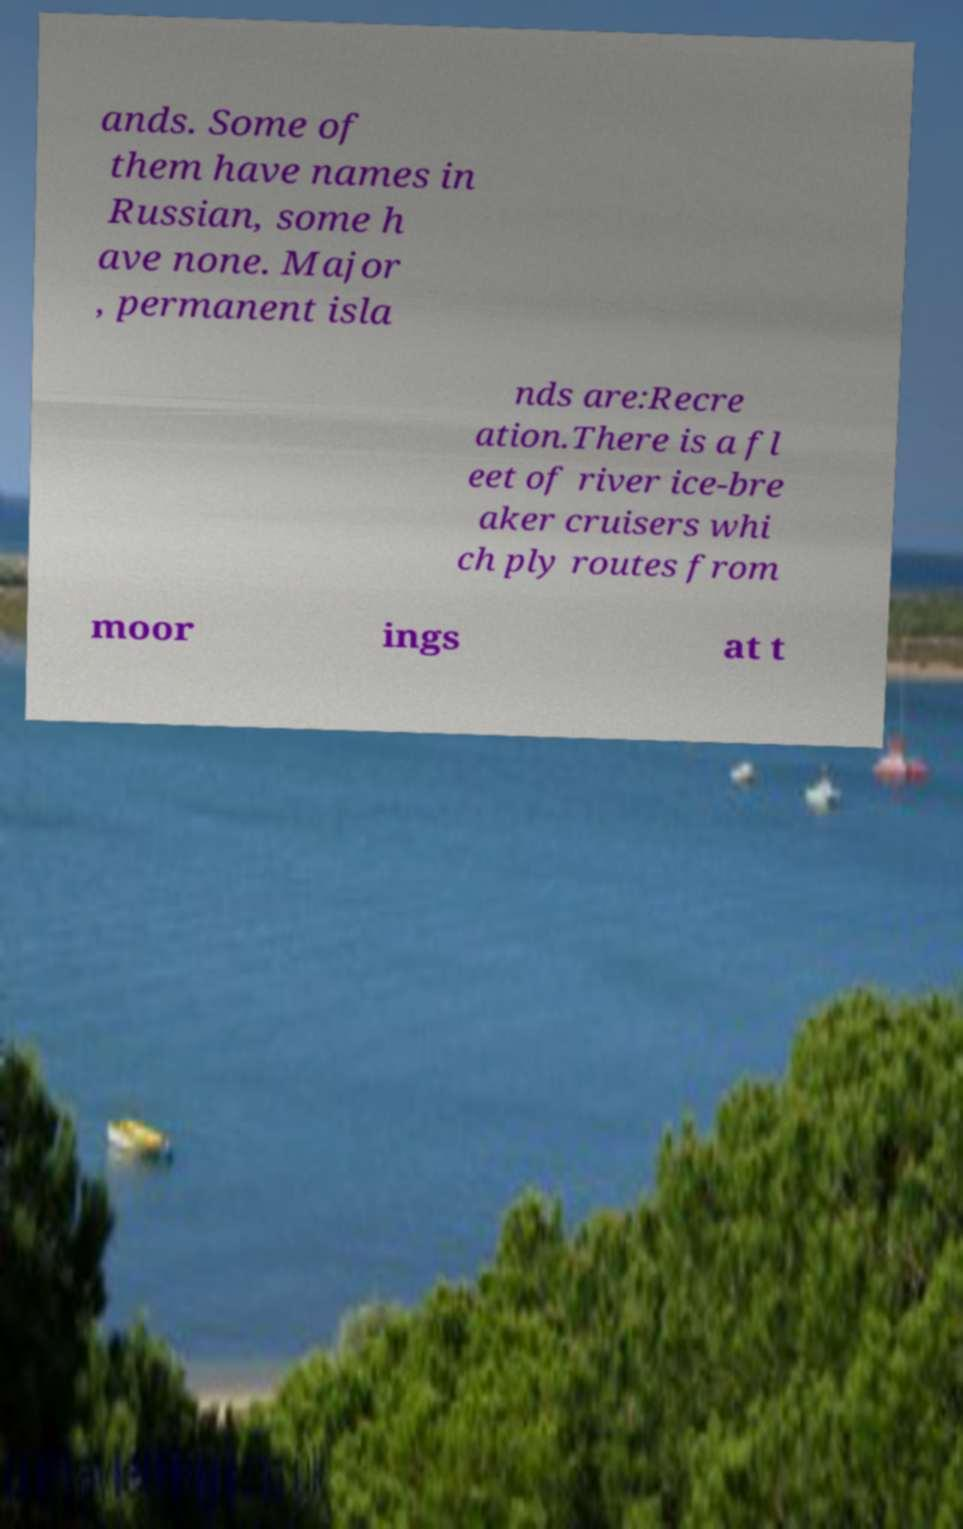Could you assist in decoding the text presented in this image and type it out clearly? ands. Some of them have names in Russian, some h ave none. Major , permanent isla nds are:Recre ation.There is a fl eet of river ice-bre aker cruisers whi ch ply routes from moor ings at t 